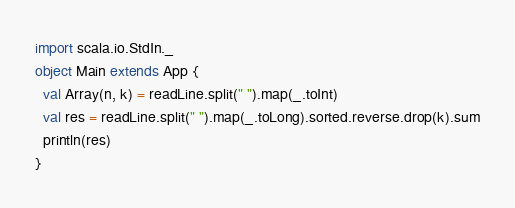<code> <loc_0><loc_0><loc_500><loc_500><_Scala_>import scala.io.StdIn._
object Main extends App {
  val Array(n, k) = readLine.split(" ").map(_.toInt)
  val res = readLine.split(" ").map(_.toLong).sorted.reverse.drop(k).sum
  println(res)
}
</code> 